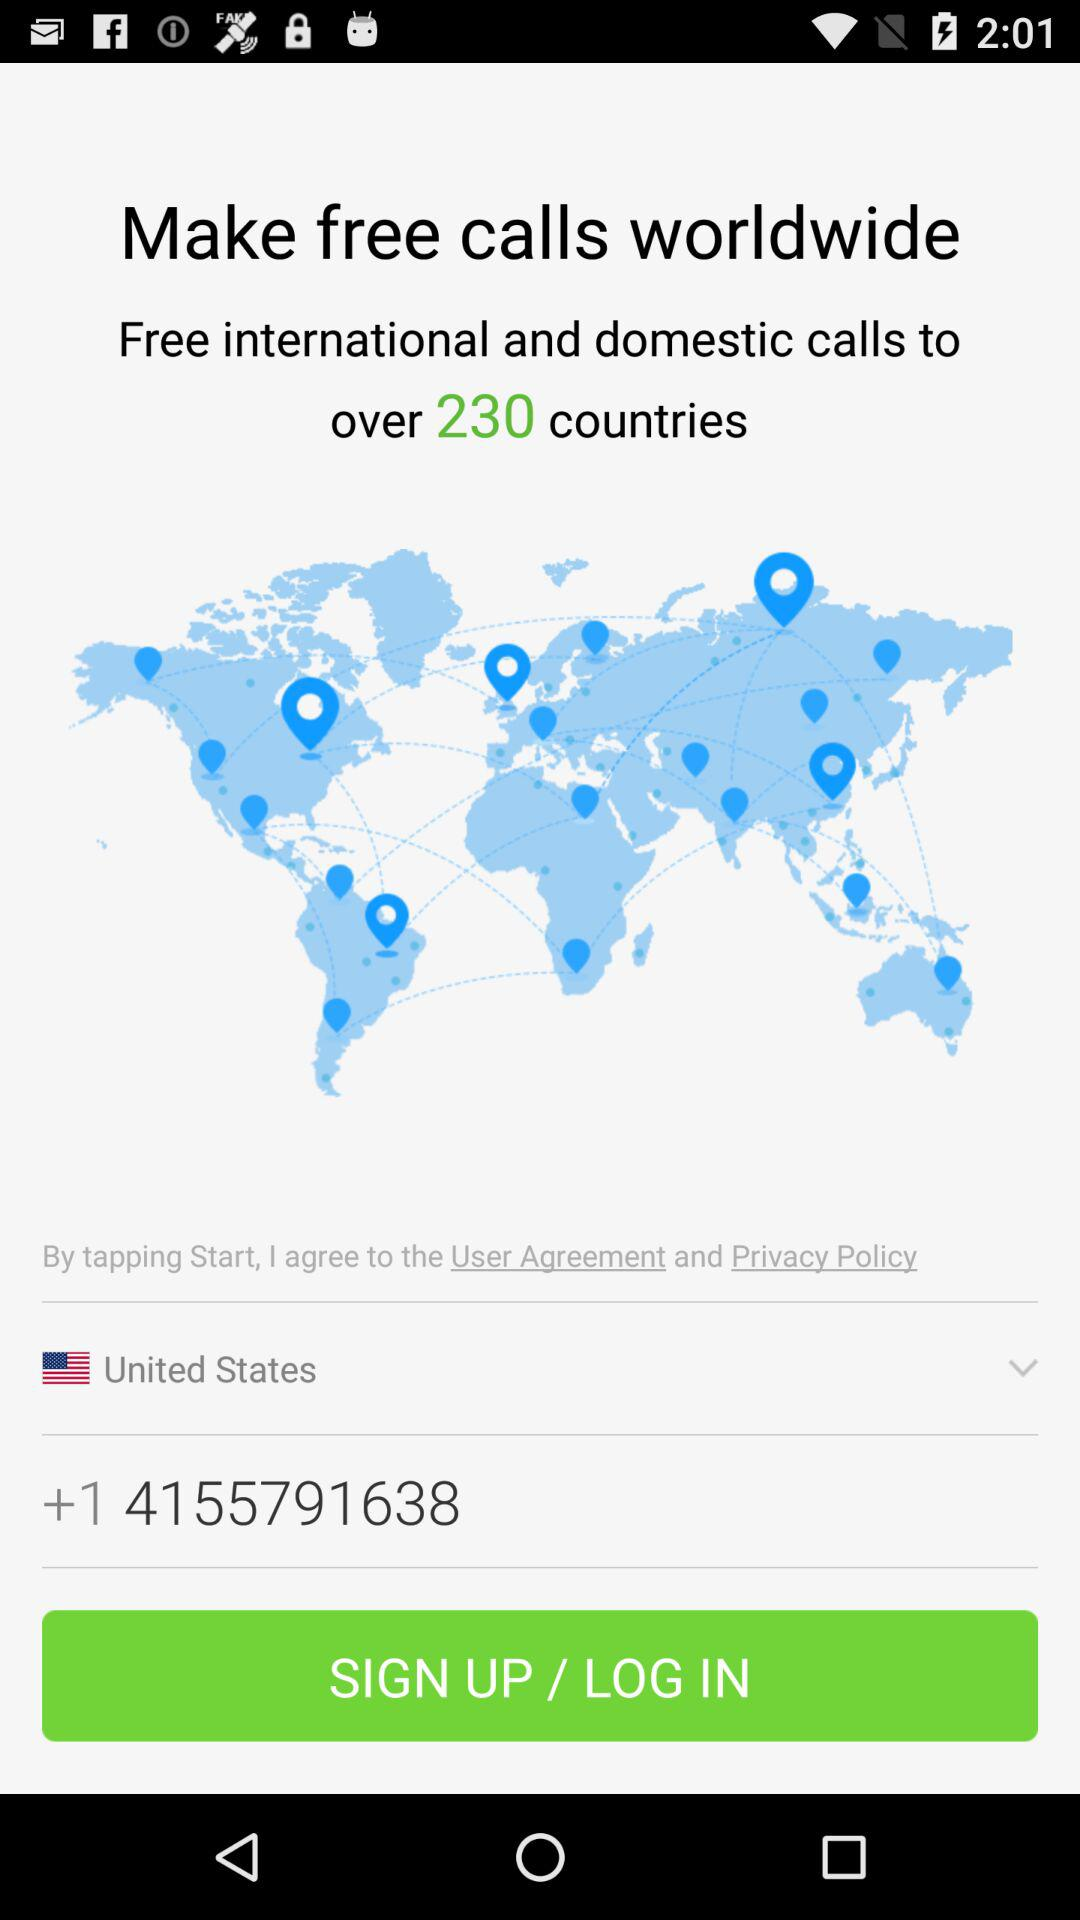What is the selected country? The selected country is the United States. 